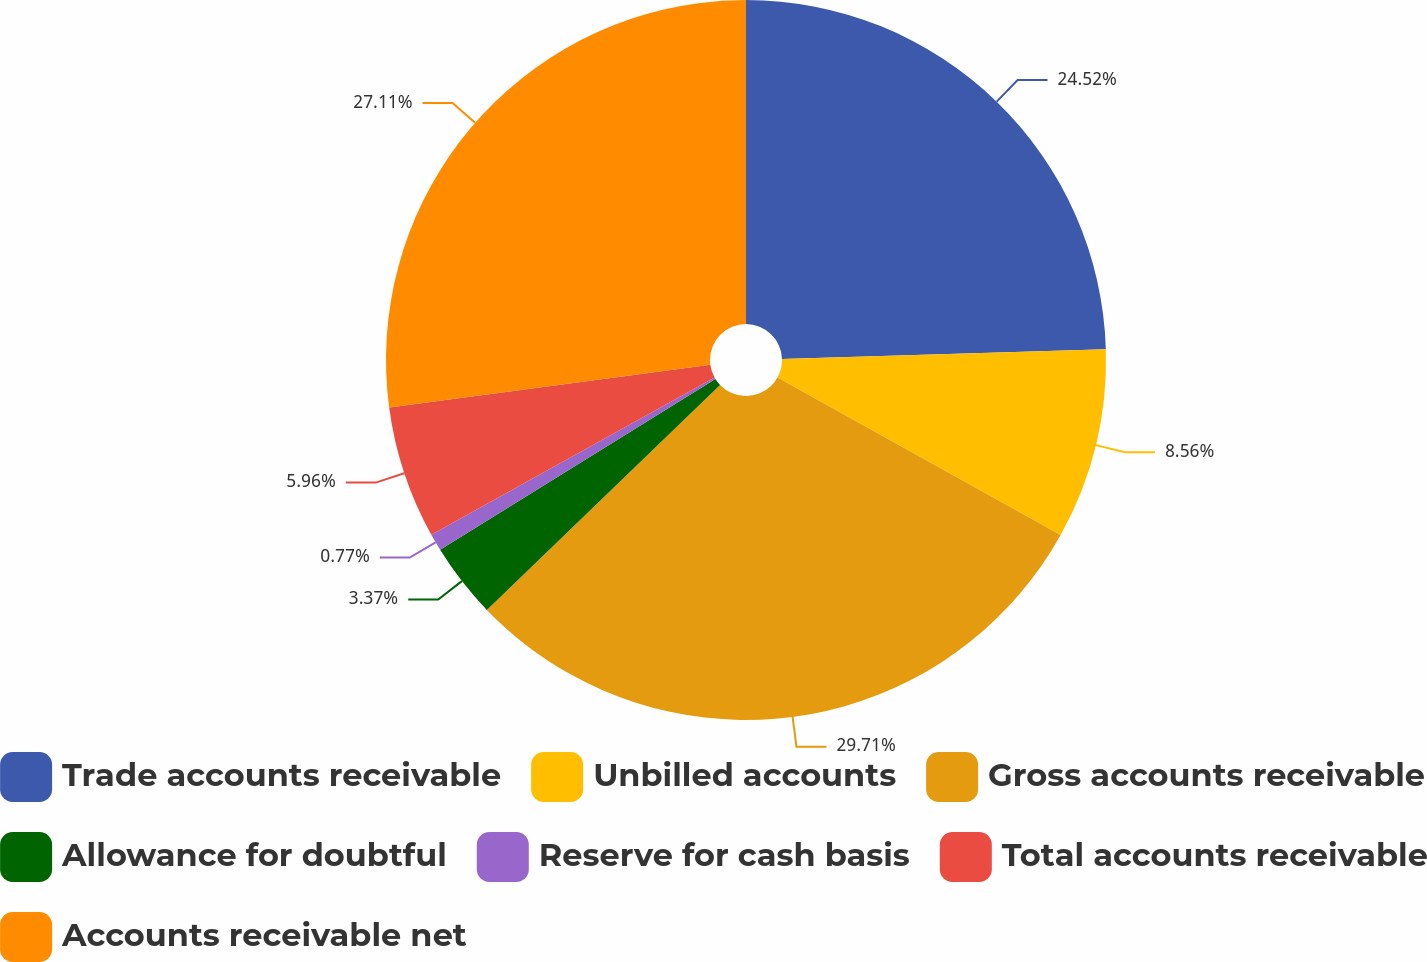Convert chart. <chart><loc_0><loc_0><loc_500><loc_500><pie_chart><fcel>Trade accounts receivable<fcel>Unbilled accounts<fcel>Gross accounts receivable<fcel>Allowance for doubtful<fcel>Reserve for cash basis<fcel>Total accounts receivable<fcel>Accounts receivable net<nl><fcel>24.52%<fcel>8.56%<fcel>29.71%<fcel>3.37%<fcel>0.77%<fcel>5.96%<fcel>27.11%<nl></chart> 